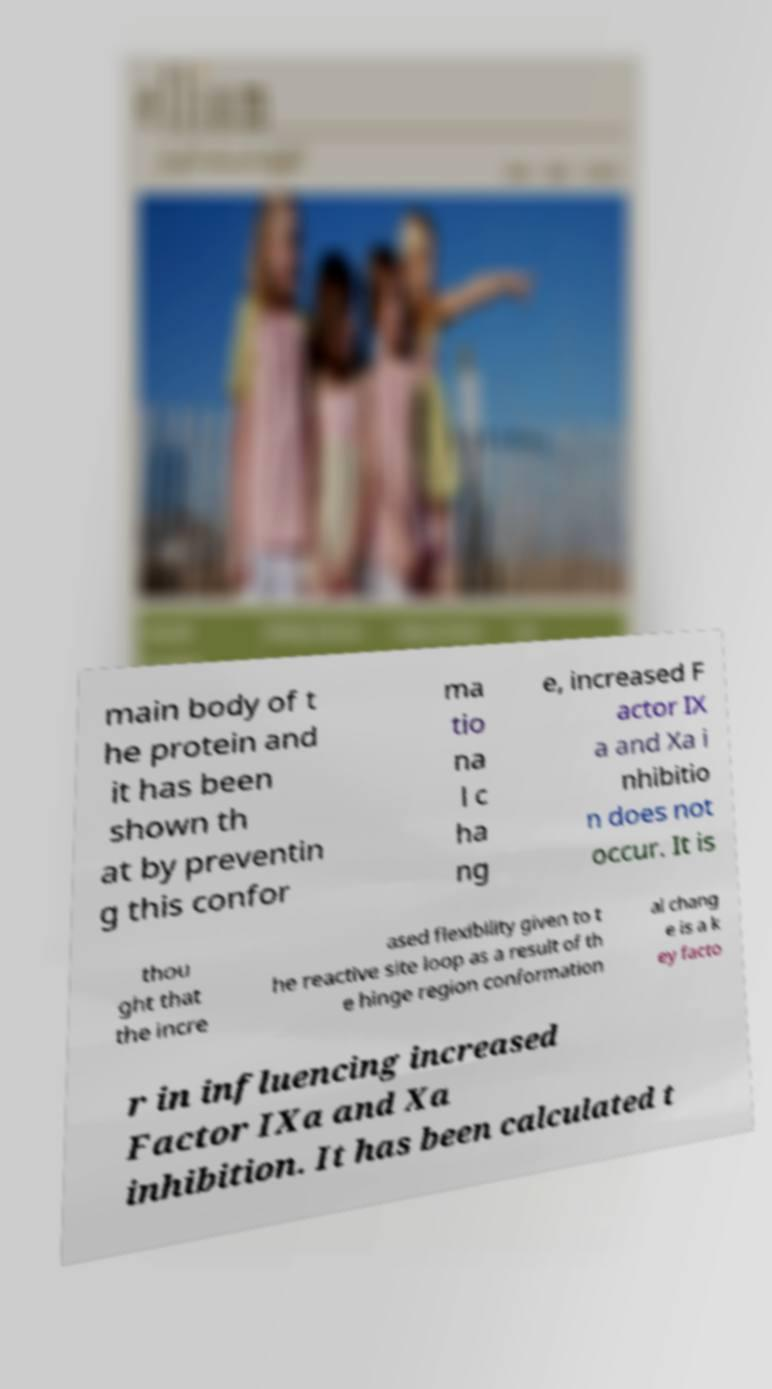There's text embedded in this image that I need extracted. Can you transcribe it verbatim? main body of t he protein and it has been shown th at by preventin g this confor ma tio na l c ha ng e, increased F actor IX a and Xa i nhibitio n does not occur. It is thou ght that the incre ased flexibility given to t he reactive site loop as a result of th e hinge region conformation al chang e is a k ey facto r in influencing increased Factor IXa and Xa inhibition. It has been calculated t 